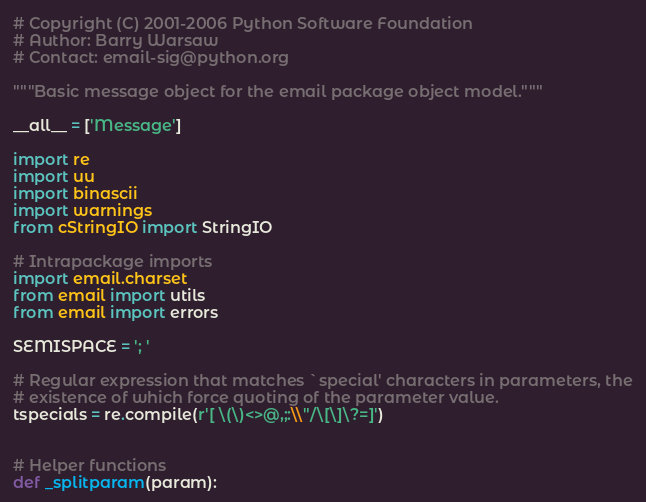Convert code to text. <code><loc_0><loc_0><loc_500><loc_500><_Python_># Copyright (C) 2001-2006 Python Software Foundation
# Author: Barry Warsaw
# Contact: email-sig@python.org

"""Basic message object for the email package object model."""

__all__ = ['Message']

import re
import uu
import binascii
import warnings
from cStringIO import StringIO

# Intrapackage imports
import email.charset
from email import utils
from email import errors

SEMISPACE = '; '

# Regular expression that matches `special' characters in parameters, the
# existence of which force quoting of the parameter value.
tspecials = re.compile(r'[ \(\)<>@,;:\\"/\[\]\?=]')


# Helper functions
def _splitparam(param):</code> 